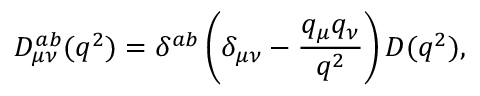Convert formula to latex. <formula><loc_0><loc_0><loc_500><loc_500>D _ { \mu \nu } ^ { a b } ( q ^ { 2 } ) = \delta ^ { a b } \left ( \delta _ { \mu \nu } - \frac { q _ { \mu } q _ { \nu } } { q ^ { 2 } } \right ) D ( q ^ { 2 } ) ,</formula> 